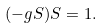Convert formula to latex. <formula><loc_0><loc_0><loc_500><loc_500>( - g S ) S = 1 .</formula> 